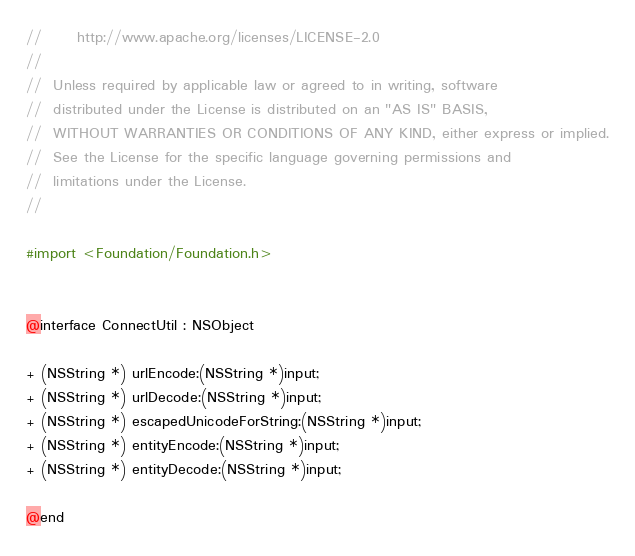Convert code to text. <code><loc_0><loc_0><loc_500><loc_500><_C_>//      http://www.apache.org/licenses/LICENSE-2.0
//
//  Unless required by applicable law or agreed to in writing, software
//  distributed under the License is distributed on an "AS IS" BASIS,
//  WITHOUT WARRANTIES OR CONDITIONS OF ANY KIND, either express or implied.
//  See the License for the specific language governing permissions and
//  limitations under the License.
//

#import <Foundation/Foundation.h>


@interface ConnectUtil : NSObject

+ (NSString *) urlEncode:(NSString *)input;
+ (NSString *) urlDecode:(NSString *)input;
+ (NSString *) escapedUnicodeForString:(NSString *)input;
+ (NSString *) entityEncode:(NSString *)input;
+ (NSString *) entityDecode:(NSString *)input;

@end
</code> 